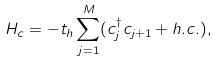<formula> <loc_0><loc_0><loc_500><loc_500>H _ { c } = - t _ { h } \sum _ { j = 1 } ^ { M } ( c ^ { \dagger } _ { j } c _ { j + 1 } + h . c . ) ,</formula> 